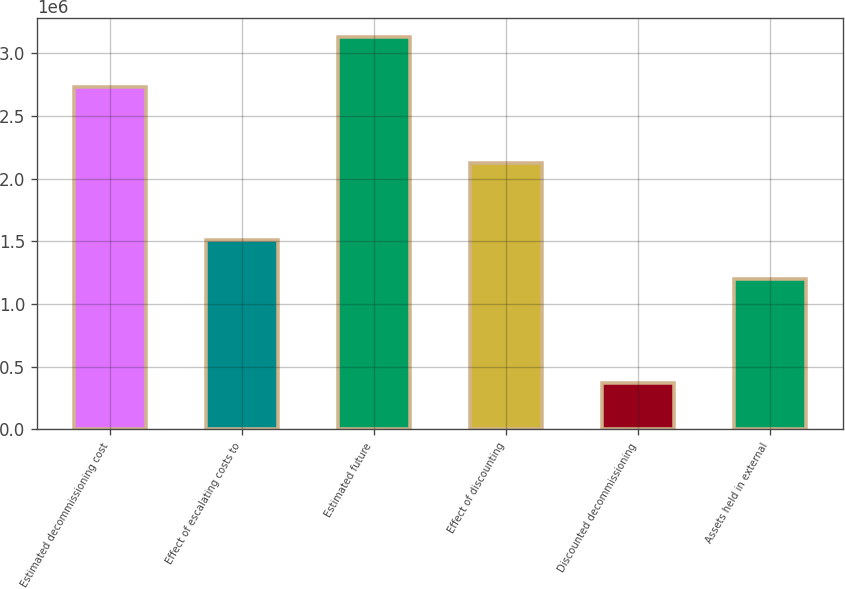Convert chart. <chart><loc_0><loc_0><loc_500><loc_500><bar_chart><fcel>Estimated decommissioning cost<fcel>Effect of escalating costs to<fcel>Estimated future<fcel>Effect of discounting<fcel>Discounted decommissioning<fcel>Assets held in external<nl><fcel>2.73371e+06<fcel>1.50729e+06<fcel>3.12683e+06<fcel>2.1205e+06<fcel>367387<fcel>1.20069e+06<nl></chart> 